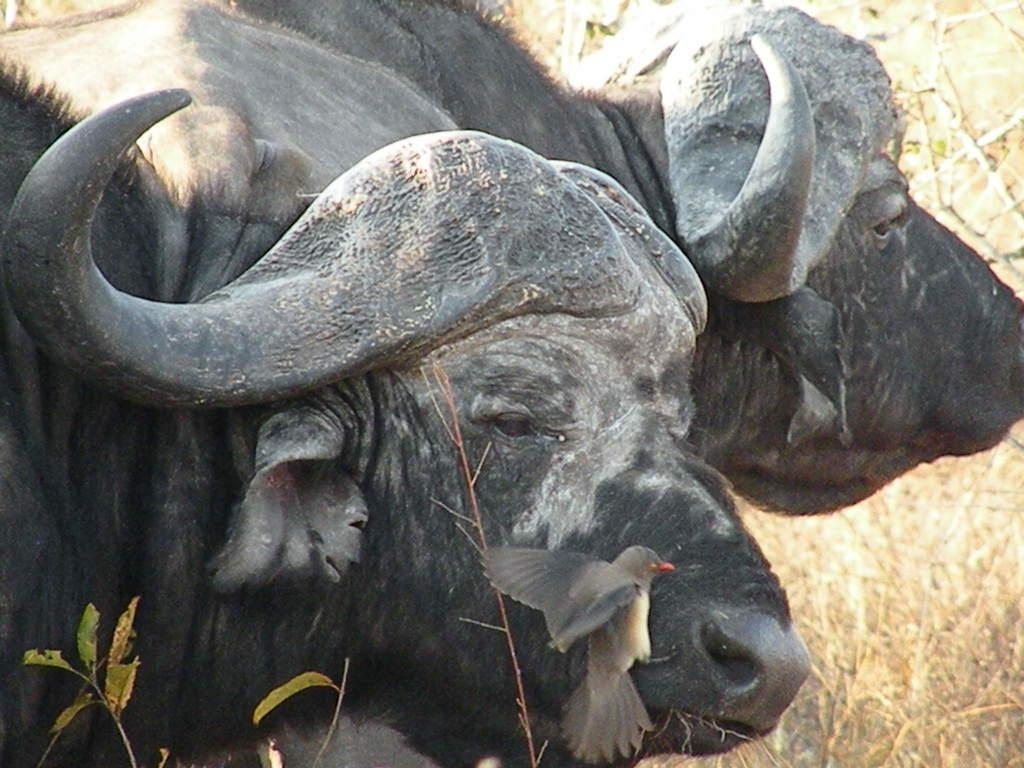What type of living organisms can be seen in the image? There are animals and a bird in the image. Can you describe the bird in the image? There is a bird in the image, but no specific details about the bird are provided. What type of plant material is visible in the image? There are leaves and dried grass in the image. What type of chess piece is the giraffe in the image? There is no giraffe or chess piece present in the image. 